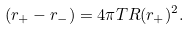<formula> <loc_0><loc_0><loc_500><loc_500>( r _ { + } - r _ { - } ) = 4 \pi T R ( r _ { + } ) ^ { 2 } .</formula> 